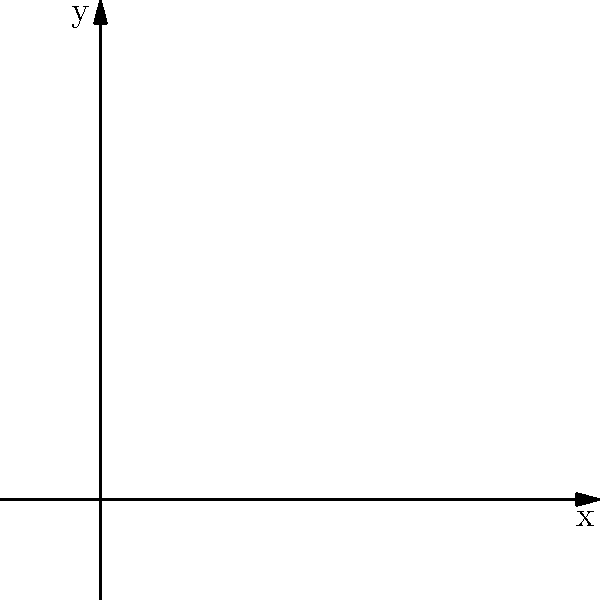In the context of numerical fluid dynamics simulations, consider the 2D vector field represented in the coordinate system above. The arrows indicate the direction and magnitude of the field, while the contour lines represent the scalar potential. How would you describe the relationship between the vector field and the scalar potential, and what implications does this have for parallel computing algorithms in fluid dynamics simulations? To answer this question, let's analyze the given vector field and scalar potential step-by-step:

1. Vector field representation:
   The arrows in the coordinate system represent the vector field. The direction of each arrow shows the flow direction, while the length indicates the magnitude of the vector at that point.

2. Scalar potential representation:
   The contour lines represent the scalar potential. Each line connects points of equal potential value.

3. Relationship between vector field and scalar potential:
   The vector field appears to be the gradient of the scalar potential. This can be observed from:
   a) The vectors are perpendicular to the contour lines of the scalar potential.
   b) The magnitude of the vectors increases as the contour lines get closer together.

4. Mathematical representation:
   If we denote the scalar potential as $\phi(x,y)$, then the vector field $\mathbf{F}(x,y)$ can be expressed as:
   $$\mathbf{F}(x,y) = \nabla \phi(x,y) = \left(\frac{\partial \phi}{\partial x}, \frac{\partial \phi}{\partial y}\right)$$

5. Implications for parallel computing algorithms:
   a) Domain decomposition: The domain can be divided into subdomains, each handled by a separate processor.
   b) Load balancing: Areas with denser contour lines (higher gradients) may require more computational resources.
   c) Communication patterns: Adjacent subdomains need to exchange boundary information, affecting the parallel algorithm's efficiency.
   d) Numerical methods: Finite difference or finite element methods can be parallelized for solving the potential equation.
   e) Data locality: The relationship between the vector field and scalar potential allows for efficient caching and memory access patterns.

6. Optimizations for parallel computing:
   a) Use of ghost cells or overlap regions to minimize communication between subdomains.
   b) Implementing adaptive mesh refinement techniques to focus computational resources on areas with high gradients.
   c) Utilizing parallel linear algebra libraries for solving the resulting systems of equations.

This representation allows for efficient parallel computation of fluid dynamics simulations by exploiting the relationship between the vector field and scalar potential.
Answer: The vector field is the gradient of the scalar potential, enabling efficient parallel domain decomposition, load balancing, and optimized communication patterns in fluid dynamics simulations. 